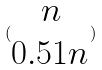Convert formula to latex. <formula><loc_0><loc_0><loc_500><loc_500>( \begin{matrix} n \\ 0 . 5 1 n \end{matrix} )</formula> 